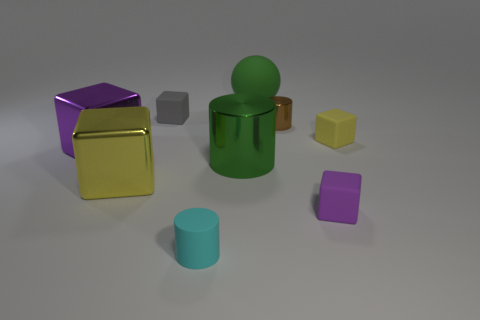Subtract all tiny yellow rubber blocks. How many blocks are left? 4 Subtract all gray blocks. How many blocks are left? 4 Subtract all cyan cubes. Subtract all brown cylinders. How many cubes are left? 5 Subtract all spheres. How many objects are left? 8 Add 9 red rubber balls. How many red rubber balls exist? 9 Subtract 1 green spheres. How many objects are left? 8 Subtract all tiny metallic spheres. Subtract all cyan things. How many objects are left? 8 Add 1 tiny yellow things. How many tiny yellow things are left? 2 